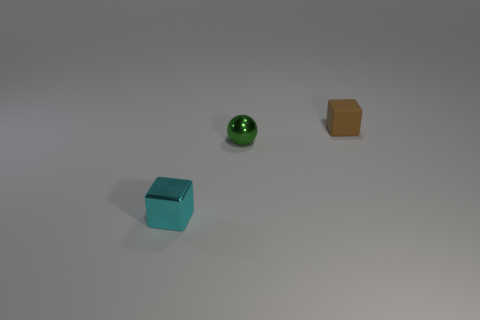How would these objects interact if the surface wasn't flat? If the surface were inclined or uneven, the sphere would likely roll due to its shape, while the two blocks, depending on their mass and the angle of the surface, might slide or remain stationary.  In what kind of lighting does this scene seem to be set? The shadows suggest a single light source shining from above, creating a soft, diffused illumination. The gentle shadow casting and lack of harsh highlights indicate indoor lighting, possibly ambient lighting or a softbox used for photography. 